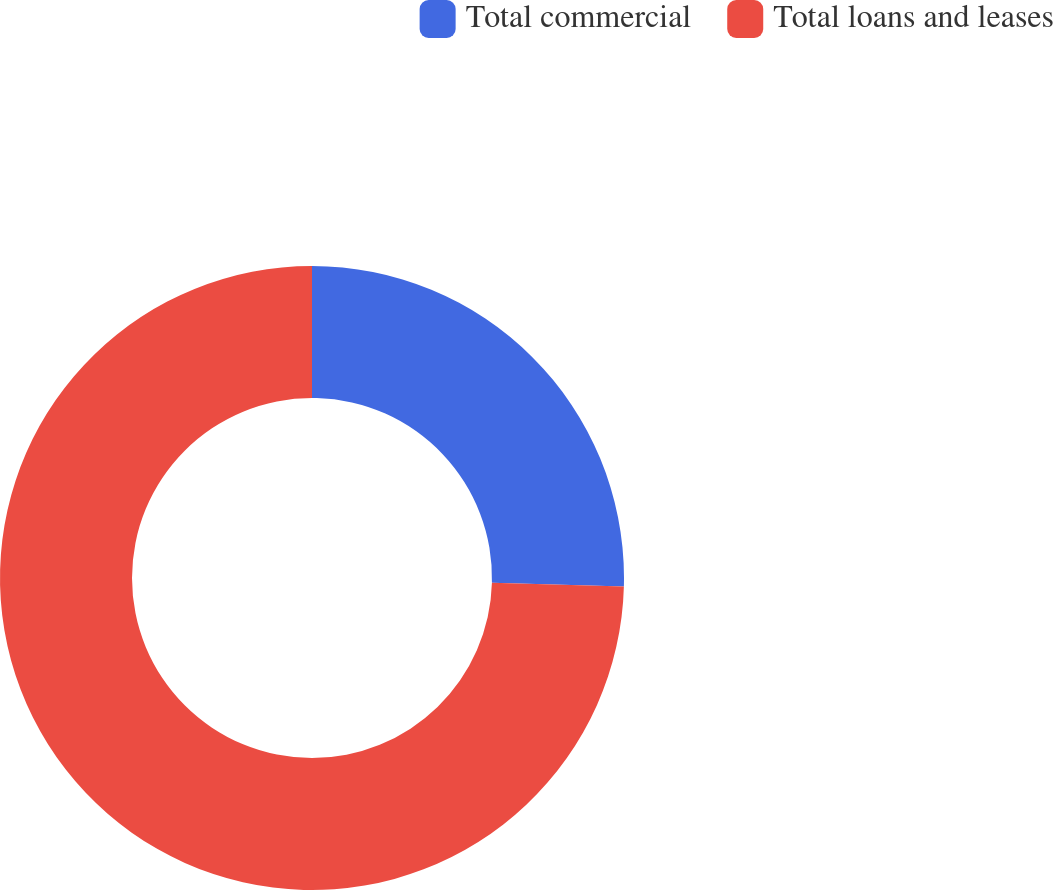<chart> <loc_0><loc_0><loc_500><loc_500><pie_chart><fcel>Total commercial<fcel>Total loans and leases<nl><fcel>25.43%<fcel>74.57%<nl></chart> 